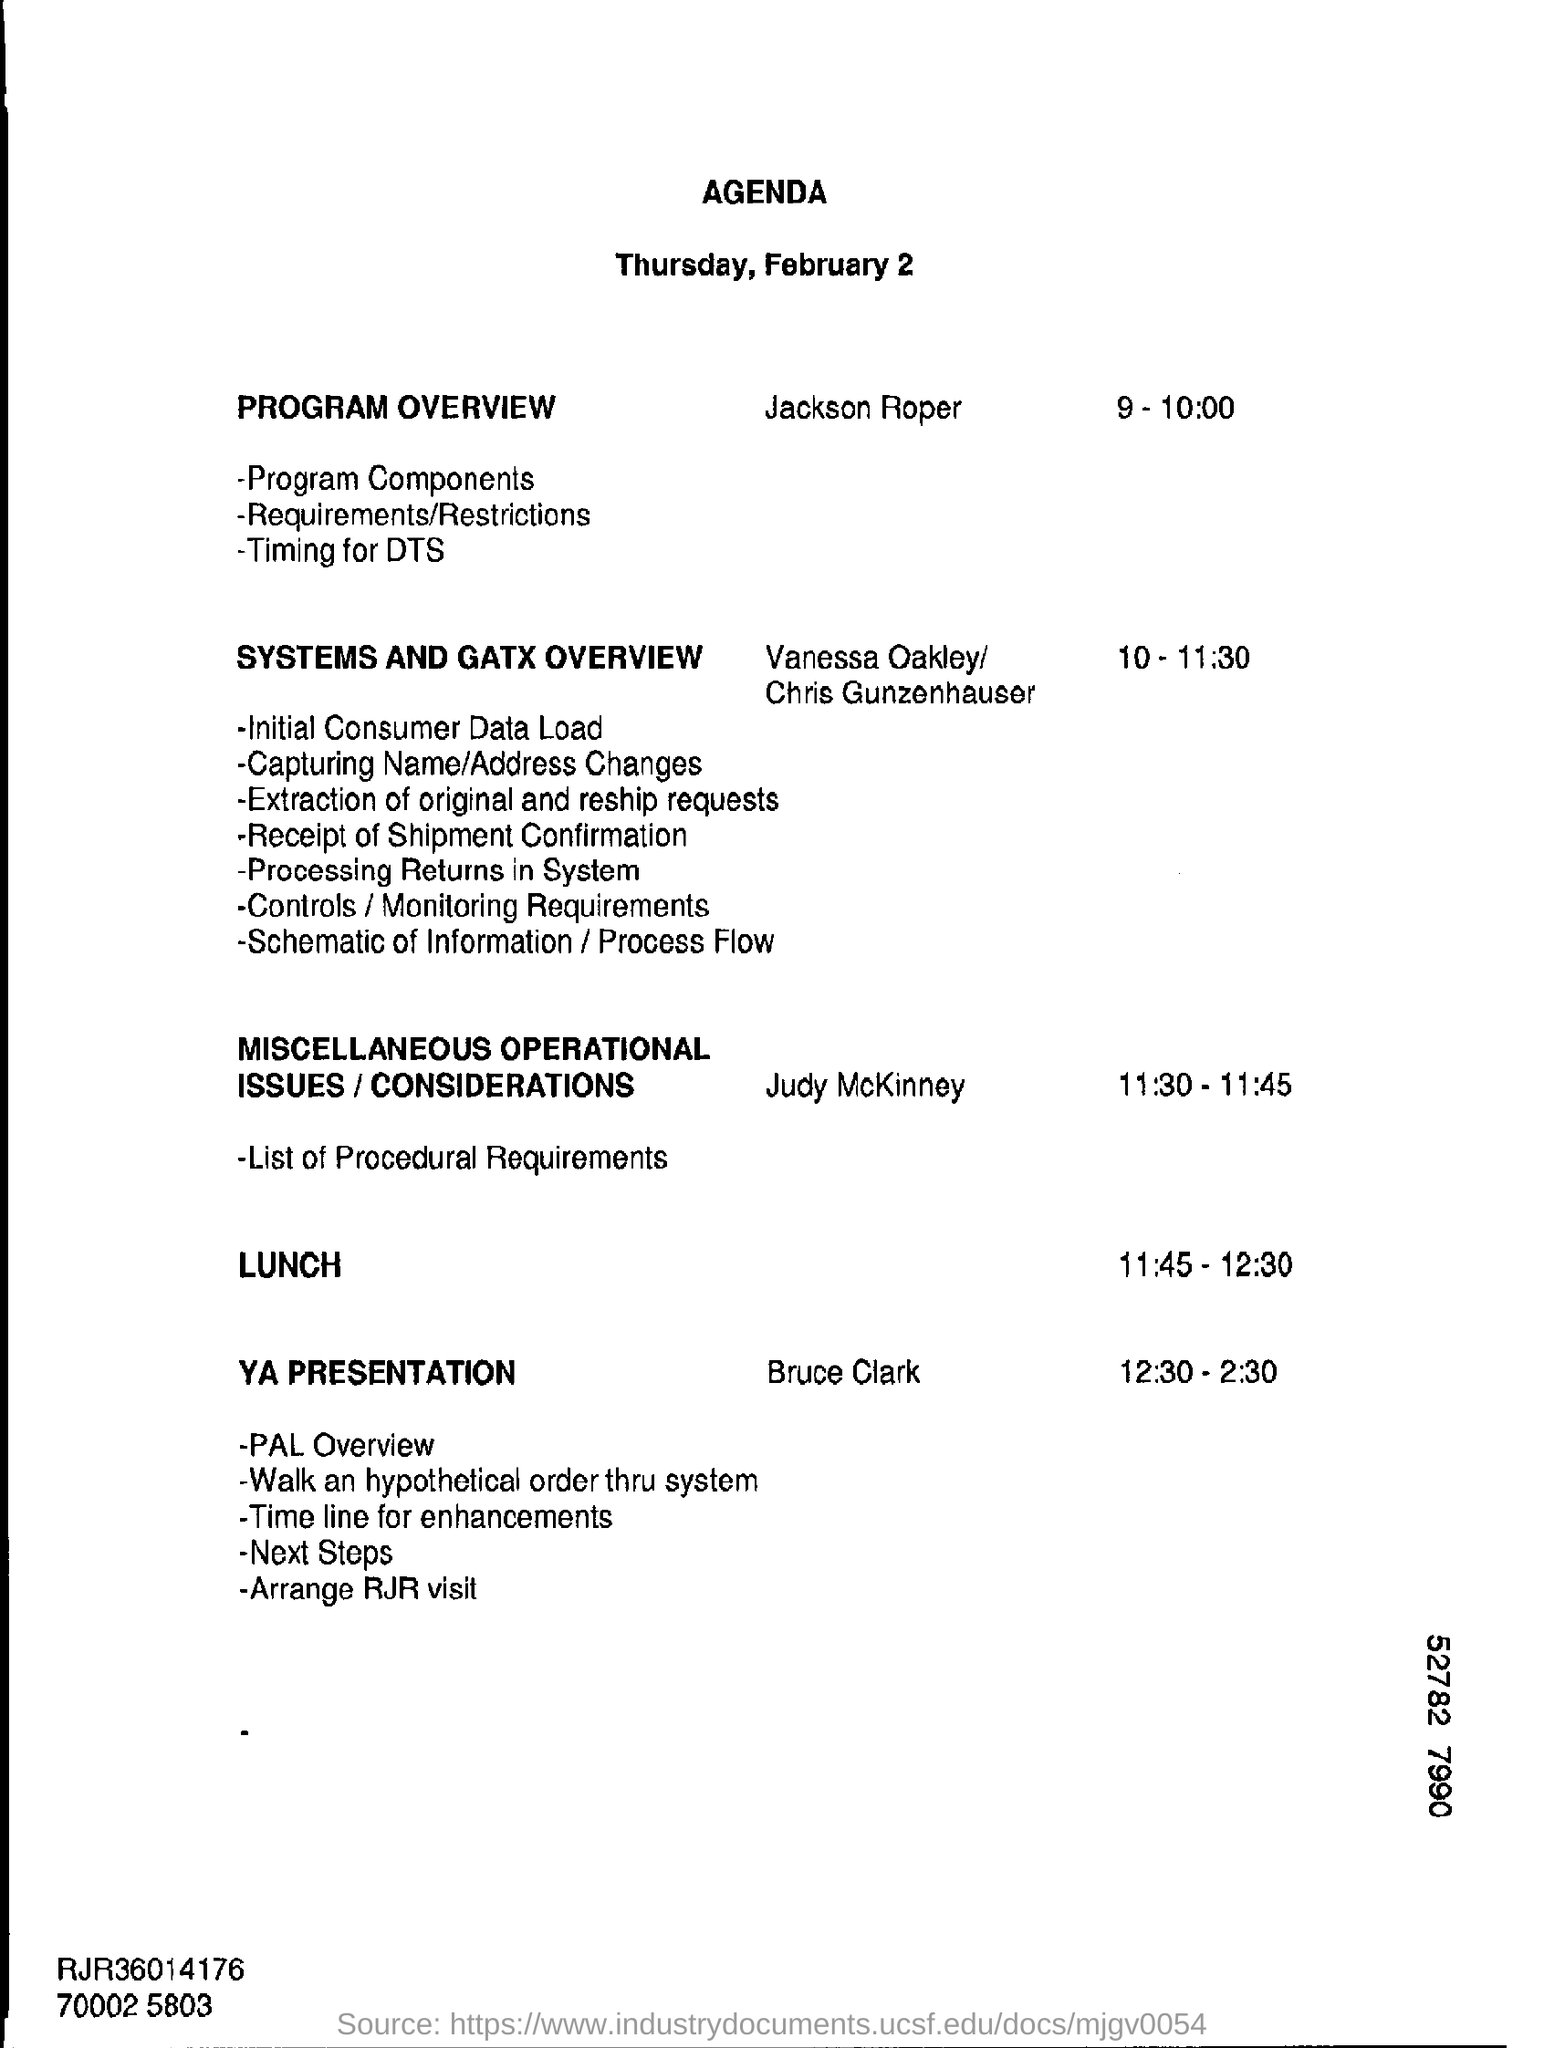List a handful of essential elements in this visual. The digit shown in the bottom right corner of the number 52782 is 7. 